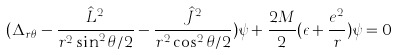Convert formula to latex. <formula><loc_0><loc_0><loc_500><loc_500>( \Delta _ { r \theta } - \frac { \hat { L } ^ { 2 } } { r ^ { 2 } \sin ^ { 2 } \theta / 2 } - \frac { \hat { J } ^ { 2 } } { r ^ { 2 } \cos ^ { 2 } \theta / 2 } ) \psi + \frac { 2 M } { 2 } ( \epsilon + \frac { e ^ { 2 } } { r } ) \psi = 0</formula> 